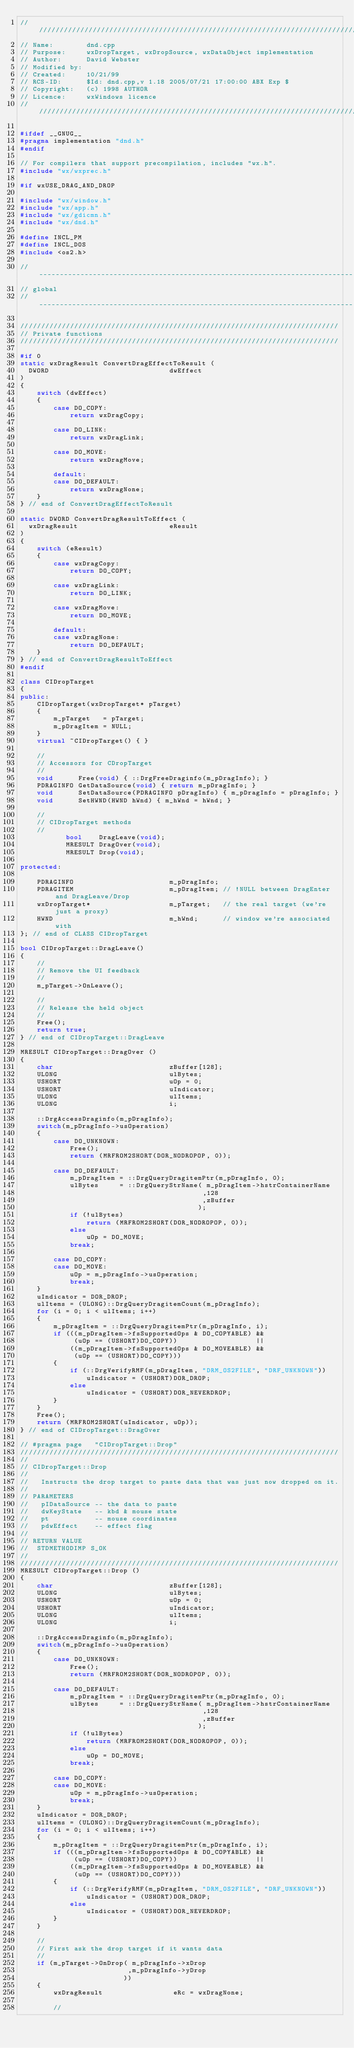Convert code to text. <code><loc_0><loc_0><loc_500><loc_500><_C++_>///////////////////////////////////////////////////////////////////////////////
// Name:        dnd.cpp
// Purpose:     wxDropTarget, wxDropSource, wxDataObject implementation
// Author:      David Webster
// Modified by:
// Created:     10/21/99
// RCS-ID:      $Id: dnd.cpp,v 1.18 2005/07/21 17:00:00 ABX Exp $
// Copyright:   (c) 1998 AUTHOR
// Licence:     wxWindows licence
///////////////////////////////////////////////////////////////////////////////

#ifdef __GNUG__
#pragma implementation "dnd.h"
#endif

// For compilers that support precompilation, includes "wx.h".
#include "wx/wxprec.h"

#if wxUSE_DRAG_AND_DROP

#include "wx/window.h"
#include "wx/app.h"
#include "wx/gdicmn.h"
#include "wx/dnd.h"

#define INCL_PM
#define INCL_DOS
#include <os2.h>

// ----------------------------------------------------------------------------
// global
// ----------------------------------------------------------------------------

/////////////////////////////////////////////////////////////////////////////
// Private functions
/////////////////////////////////////////////////////////////////////////////

#if 0
static wxDragResult ConvertDragEffectToResult (
  DWORD                             dwEffect
)
{
    switch (dwEffect)
    {
        case DO_COPY:
            return wxDragCopy;

        case DO_LINK:
            return wxDragLink;

        case DO_MOVE:
            return wxDragMove;

        default:
        case DO_DEFAULT:
            return wxDragNone;
    }
} // end of ConvertDragEffectToResult

static DWORD ConvertDragResultToEffect (
  wxDragResult                      eResult
)
{
    switch (eResult)
    {
        case wxDragCopy:
            return DO_COPY;

        case wxDragLink:
            return DO_LINK;

        case wxDragMove:
            return DO_MOVE;

        default:
        case wxDragNone:
            return DO_DEFAULT;
    }
} // end of ConvertDragResultToEffect
#endif

class CIDropTarget
{
public:
    CIDropTarget(wxDropTarget* pTarget)
    {
        m_pTarget   = pTarget;
        m_pDragItem = NULL;
    }
    virtual ~CIDropTarget() { }

    //
    // Accessors for CDropTarget
    //
    void      Free(void) { ::DrgFreeDraginfo(m_pDragInfo); }
    PDRAGINFO GetDataSource(void) { return m_pDragInfo; }
    void      SetDataSource(PDRAGINFO pDragInfo) { m_pDragInfo = pDragInfo; }
    void      SetHWND(HWND hWnd) { m_hWnd = hWnd; }

    //
    // CIDropTarget methods
    //
           bool    DragLeave(void);
           MRESULT DragOver(void);
           MRESULT Drop(void);

protected:

    PDRAGINFO                       m_pDragInfo;
    PDRAGITEM                       m_pDragItem; // !NULL between DragEnter and DragLeave/Drop
    wxDropTarget*                   m_pTarget;   // the real target (we're just a proxy)
    HWND                            m_hWnd;      // window we're associated with
}; // end of CLASS CIDropTarget

bool CIDropTarget::DragLeave()
{
    //
    // Remove the UI feedback
    //
    m_pTarget->OnLeave();

    //
    // Release the held object
    //
    Free();
    return true;
} // end of CIDropTarget::DragLeave

MRESULT CIDropTarget::DragOver ()
{
    char                            zBuffer[128];
    ULONG                           ulBytes;
    USHORT                          uOp = 0;
    USHORT                          uIndicator;
    ULONG                           ulItems;
    ULONG                           i;

    ::DrgAccessDraginfo(m_pDragInfo);
    switch(m_pDragInfo->usOperation)
    {
        case DO_UNKNOWN:
            Free();
            return (MRFROM2SHORT(DOR_NODROPOP, 0));

        case DO_DEFAULT:
            m_pDragItem = ::DrgQueryDragitemPtr(m_pDragInfo, 0);
            ulBytes     = ::DrgQueryStrName( m_pDragItem->hstrContainerName
                                            ,128
                                            ,zBuffer
                                           );
            if (!ulBytes)
                return (MRFROM2SHORT(DOR_NODROPOP, 0));
            else
                uOp = DO_MOVE;
            break;

        case DO_COPY:
        case DO_MOVE:
            uOp = m_pDragInfo->usOperation;
            break;
    }
    uIndicator = DOR_DROP;
    ulItems = (ULONG)::DrgQueryDragitemCount(m_pDragInfo);
    for (i = 0; i < ulItems; i++)
    {
        m_pDragItem = ::DrgQueryDragitemPtr(m_pDragInfo, i);
        if (((m_pDragItem->fsSupportedOps & DO_COPYABLE) &&
             (uOp == (USHORT)DO_COPY))                   ||
            ((m_pDragItem->fsSupportedOps & DO_MOVEABLE) &&
             (uOp == (USHORT)DO_COPY)))
        {
            if (::DrgVerifyRMF(m_pDragItem, "DRM_OS2FILE", "DRF_UNKNOWN"))
                uIndicator = (USHORT)DOR_DROP;
            else
                uIndicator = (USHORT)DOR_NEVERDROP;
        }
    }
    Free();
    return (MRFROM2SHORT(uIndicator, uOp));
} // end of CIDropTarget::DragOver

// #pragma page   "CIDropTarget::Drop"
/////////////////////////////////////////////////////////////////////////////
//
// CIDropTarget::Drop
//
//   Instructs the drop target to paste data that was just now dropped on it.
//
// PARAMETERS
//   pIDataSource -- the data to paste
//   dwKeyState   -- kbd & mouse state
//   pt           -- mouse coordinates
//   pdwEffect    -- effect flag
//
// RETURN VALUE
//  STDMETHODIMP S_OK
//
/////////////////////////////////////////////////////////////////////////////
MRESULT CIDropTarget::Drop ()
{
    char                            zBuffer[128];
    ULONG                           ulBytes;
    USHORT                          uOp = 0;
    USHORT                          uIndicator;
    ULONG                           ulItems;
    ULONG                           i;

    ::DrgAccessDraginfo(m_pDragInfo);
    switch(m_pDragInfo->usOperation)
    {
        case DO_UNKNOWN:
            Free();
            return (MRFROM2SHORT(DOR_NODROPOP, 0));

        case DO_DEFAULT:
            m_pDragItem = ::DrgQueryDragitemPtr(m_pDragInfo, 0);
            ulBytes     = ::DrgQueryStrName( m_pDragItem->hstrContainerName
                                            ,128
                                            ,zBuffer
                                           );
            if (!ulBytes)
                return (MRFROM2SHORT(DOR_NODROPOP, 0));
            else
                uOp = DO_MOVE;
            break;

        case DO_COPY:
        case DO_MOVE:
            uOp = m_pDragInfo->usOperation;
            break;
    }
    uIndicator = DOR_DROP;
    ulItems = (ULONG)::DrgQueryDragitemCount(m_pDragInfo);
    for (i = 0; i < ulItems; i++)
    {
        m_pDragItem = ::DrgQueryDragitemPtr(m_pDragInfo, i);
        if (((m_pDragItem->fsSupportedOps & DO_COPYABLE) &&
             (uOp == (USHORT)DO_COPY))                   ||
            ((m_pDragItem->fsSupportedOps & DO_MOVEABLE) &&
             (uOp == (USHORT)DO_COPY)))
        {
            if (::DrgVerifyRMF(m_pDragItem, "DRM_OS2FILE", "DRF_UNKNOWN"))
                uIndicator = (USHORT)DOR_DROP;
            else
                uIndicator = (USHORT)DOR_NEVERDROP;
        }
    }

    //
    // First ask the drop target if it wants data
    //
    if (m_pTarget->OnDrop( m_pDragInfo->xDrop
                          ,m_pDragInfo->yDrop
                         ))
    {
        wxDragResult                 eRc = wxDragNone;

        //</code> 